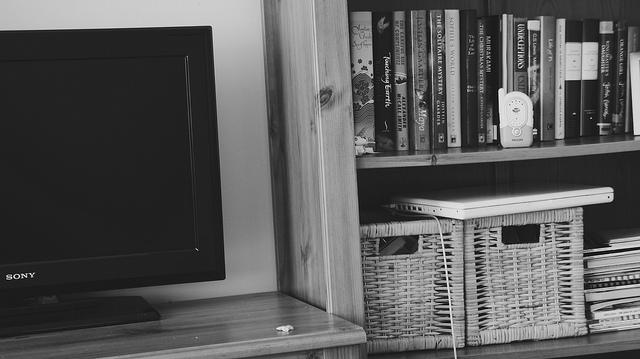Are the books really black, white and gray?
Be succinct. No. Is this in color or black and white?
Concise answer only. Black and white. Is the screen on?
Quick response, please. No. Does the display case need to be tidied?
Write a very short answer. No. Is this bookshelf cluttered?
Answer briefly. No. 